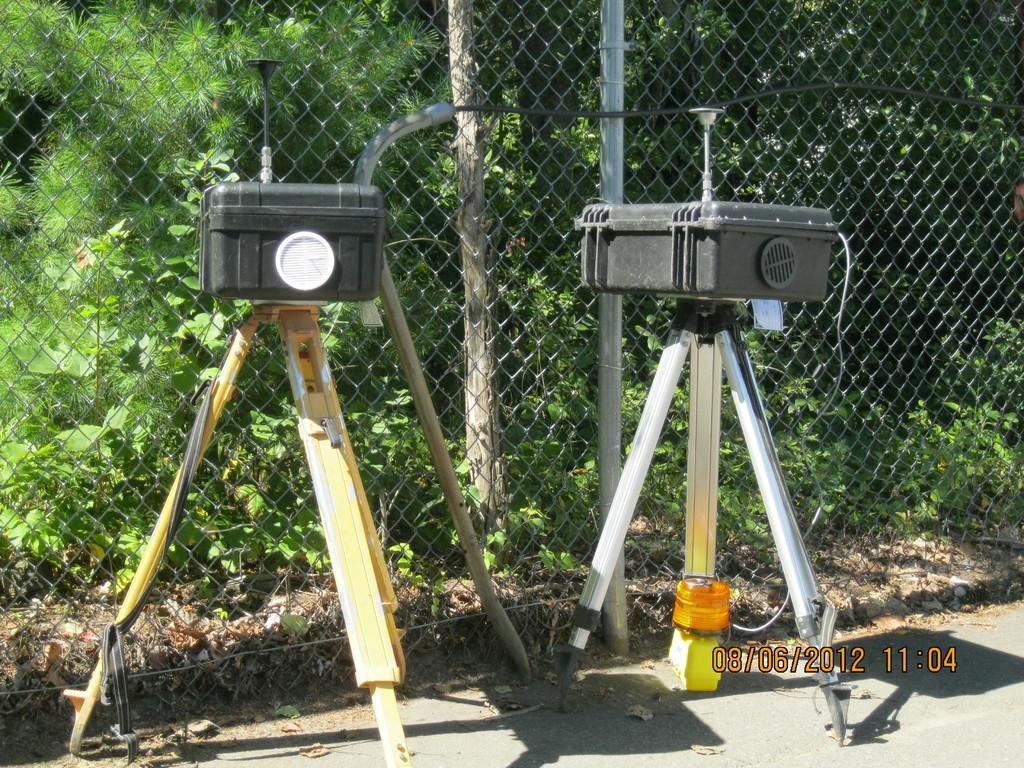What objects are on tripods in the image? There are devices on tripods in the image. How are the tripods positioned in the image? The tripods are placed on the ground. What can be seen in the background of the image? There is a wooden pole, a metal fence, plants, and a group of trees in the background of the image. What type of knowledge can be gained from the amusement park in the image? There is no amusement park present in the image, so no knowledge can be gained from it. 